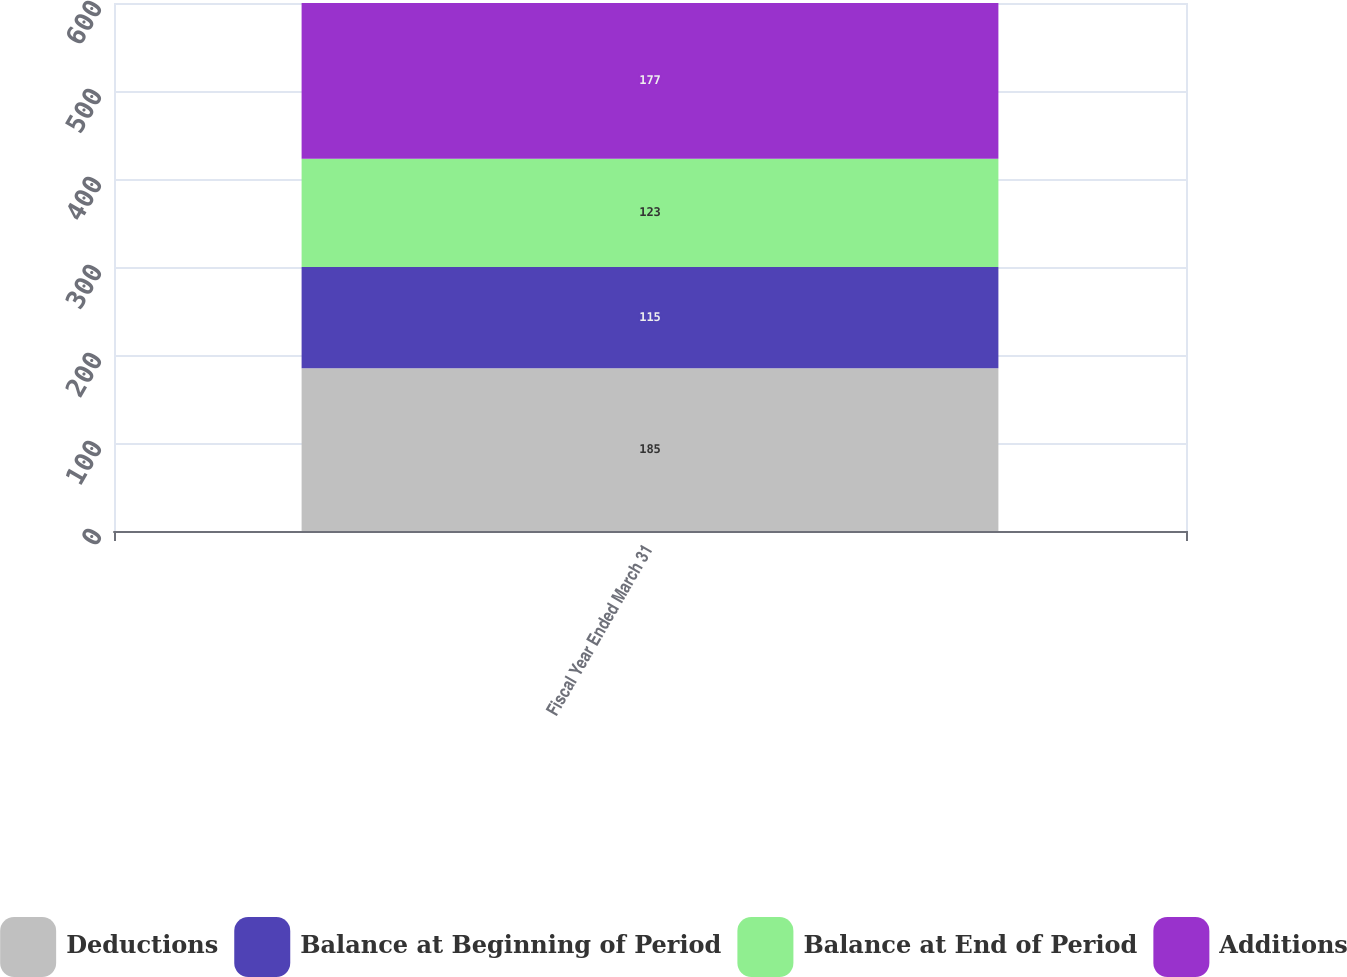Convert chart to OTSL. <chart><loc_0><loc_0><loc_500><loc_500><stacked_bar_chart><ecel><fcel>Fiscal Year Ended March 31<nl><fcel>Deductions<fcel>185<nl><fcel>Balance at Beginning of Period<fcel>115<nl><fcel>Balance at End of Period<fcel>123<nl><fcel>Additions<fcel>177<nl></chart> 